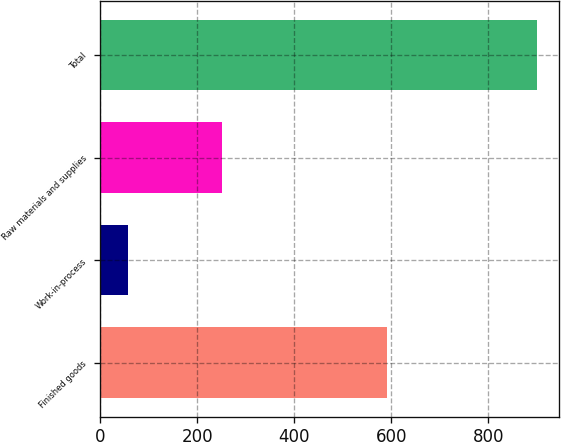<chart> <loc_0><loc_0><loc_500><loc_500><bar_chart><fcel>Finished goods<fcel>Work-in-process<fcel>Raw materials and supplies<fcel>Total<nl><fcel>591<fcel>57<fcel>252<fcel>900<nl></chart> 